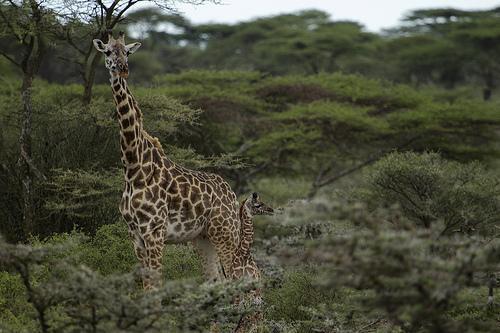How many giraffes are there?
Give a very brief answer. 2. How many dinosaurs are in the picture?
Give a very brief answer. 0. How many people are standing on the giraffes?
Give a very brief answer. 0. 